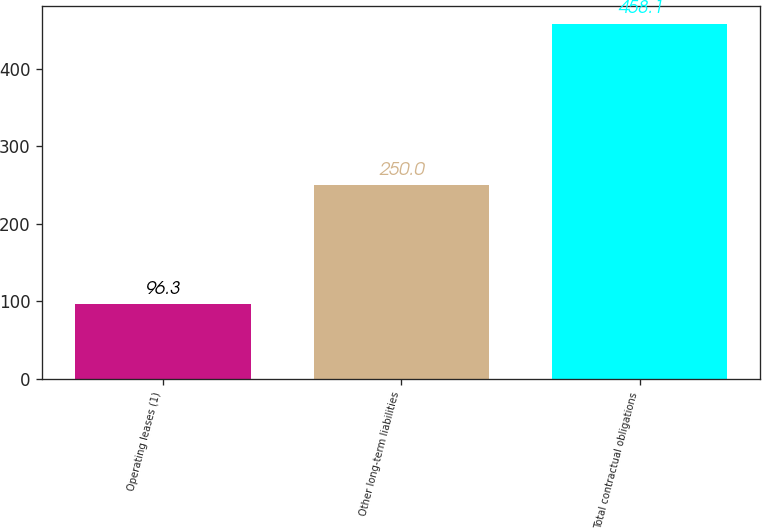Convert chart to OTSL. <chart><loc_0><loc_0><loc_500><loc_500><bar_chart><fcel>Operating leases (1)<fcel>Other long-term liabilities<fcel>Total contractual obligations<nl><fcel>96.3<fcel>250<fcel>458.1<nl></chart> 